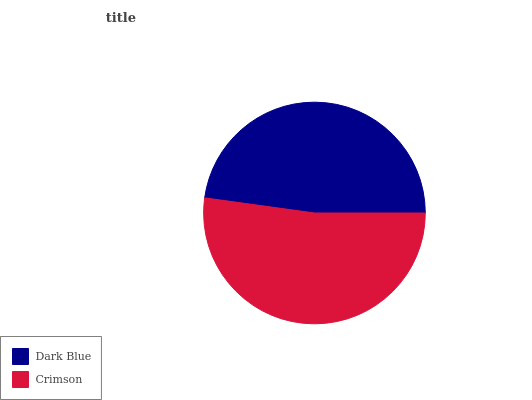Is Dark Blue the minimum?
Answer yes or no. Yes. Is Crimson the maximum?
Answer yes or no. Yes. Is Crimson the minimum?
Answer yes or no. No. Is Crimson greater than Dark Blue?
Answer yes or no. Yes. Is Dark Blue less than Crimson?
Answer yes or no. Yes. Is Dark Blue greater than Crimson?
Answer yes or no. No. Is Crimson less than Dark Blue?
Answer yes or no. No. Is Crimson the high median?
Answer yes or no. Yes. Is Dark Blue the low median?
Answer yes or no. Yes. Is Dark Blue the high median?
Answer yes or no. No. Is Crimson the low median?
Answer yes or no. No. 